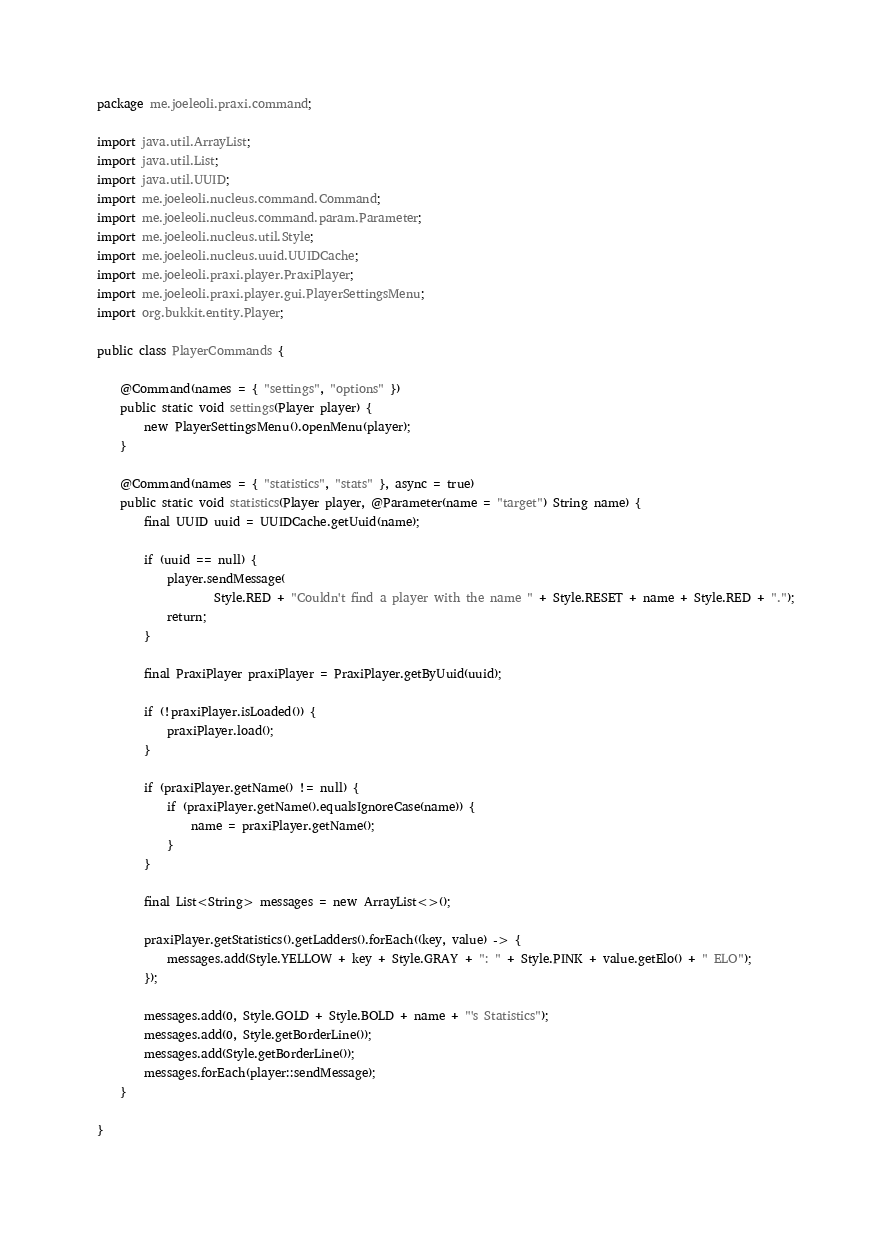Convert code to text. <code><loc_0><loc_0><loc_500><loc_500><_Java_>package me.joeleoli.praxi.command;

import java.util.ArrayList;
import java.util.List;
import java.util.UUID;
import me.joeleoli.nucleus.command.Command;
import me.joeleoli.nucleus.command.param.Parameter;
import me.joeleoli.nucleus.util.Style;
import me.joeleoli.nucleus.uuid.UUIDCache;
import me.joeleoli.praxi.player.PraxiPlayer;
import me.joeleoli.praxi.player.gui.PlayerSettingsMenu;
import org.bukkit.entity.Player;

public class PlayerCommands {

	@Command(names = { "settings", "options" })
	public static void settings(Player player) {
		new PlayerSettingsMenu().openMenu(player);
	}

	@Command(names = { "statistics", "stats" }, async = true)
	public static void statistics(Player player, @Parameter(name = "target") String name) {
		final UUID uuid = UUIDCache.getUuid(name);

		if (uuid == null) {
			player.sendMessage(
					Style.RED + "Couldn't find a player with the name " + Style.RESET + name + Style.RED + ".");
			return;
		}

		final PraxiPlayer praxiPlayer = PraxiPlayer.getByUuid(uuid);

		if (!praxiPlayer.isLoaded()) {
			praxiPlayer.load();
		}

		if (praxiPlayer.getName() != null) {
			if (praxiPlayer.getName().equalsIgnoreCase(name)) {
				name = praxiPlayer.getName();
			}
		}

		final List<String> messages = new ArrayList<>();

		praxiPlayer.getStatistics().getLadders().forEach((key, value) -> {
			messages.add(Style.YELLOW + key + Style.GRAY + ": " + Style.PINK + value.getElo() + " ELO");
		});

		messages.add(0, Style.GOLD + Style.BOLD + name + "'s Statistics");
		messages.add(0, Style.getBorderLine());
		messages.add(Style.getBorderLine());
		messages.forEach(player::sendMessage);
	}

}
</code> 